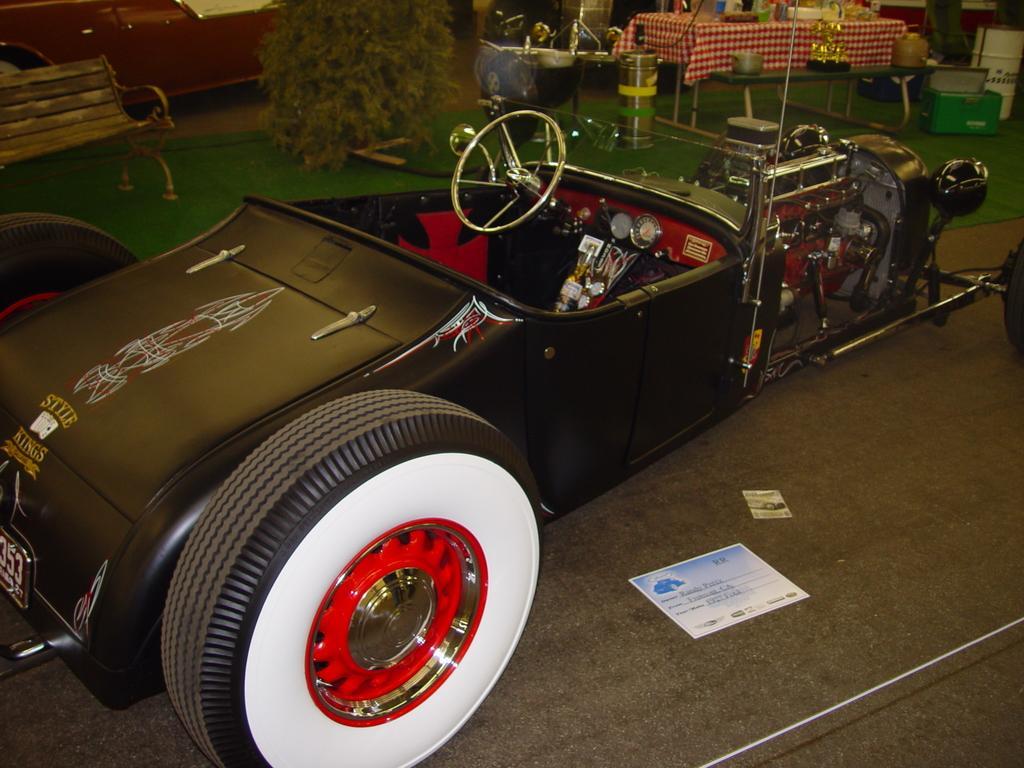How would you summarize this image in a sentence or two? In this image I see a car over here and I see the path and over here I see the green carpet and I see a bench over here and I see the tables on which there are few things and I see 2 papers over here and I see the white color wire over here and I see the plant over here. 